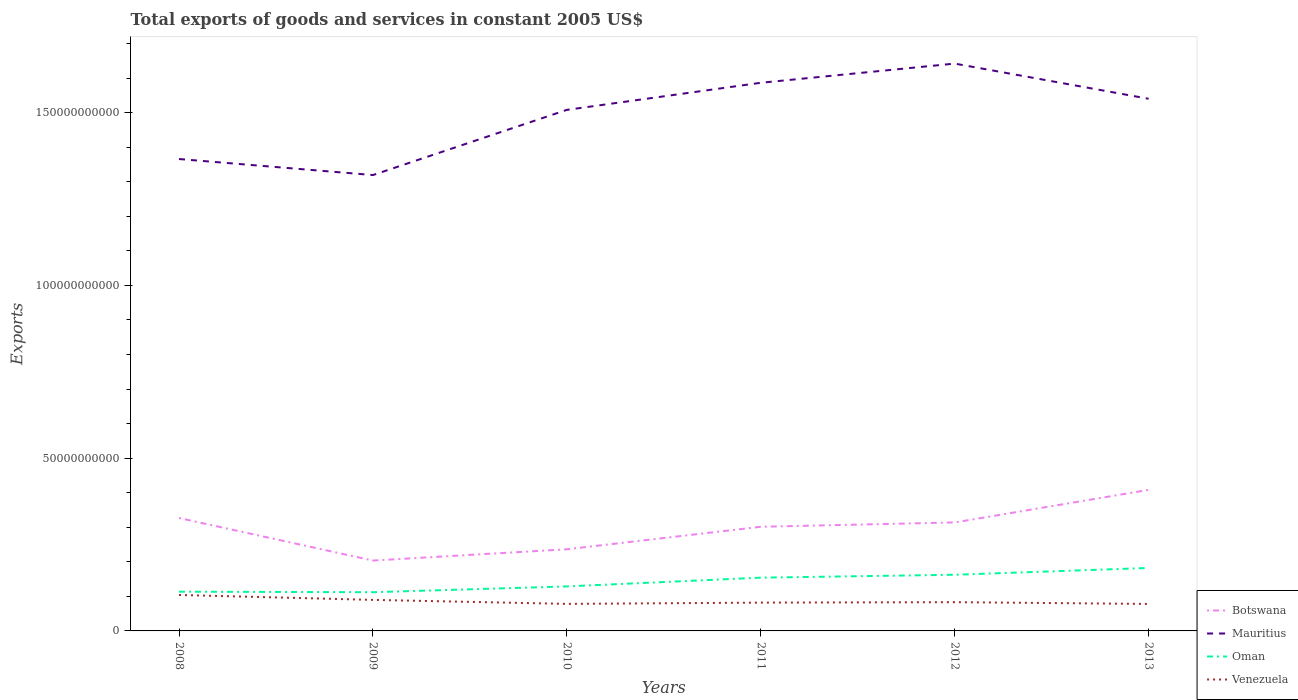How many different coloured lines are there?
Provide a short and direct response. 4. Is the number of lines equal to the number of legend labels?
Offer a terse response. Yes. Across all years, what is the maximum total exports of goods and services in Oman?
Your answer should be very brief. 1.12e+1. In which year was the total exports of goods and services in Oman maximum?
Your answer should be compact. 2009. What is the total total exports of goods and services in Venezuela in the graph?
Give a very brief answer. 2.22e+09. What is the difference between the highest and the second highest total exports of goods and services in Botswana?
Your answer should be very brief. 2.05e+1. What is the difference between the highest and the lowest total exports of goods and services in Botswana?
Keep it short and to the point. 4. How many lines are there?
Provide a succinct answer. 4. What is the difference between two consecutive major ticks on the Y-axis?
Give a very brief answer. 5.00e+1. Are the values on the major ticks of Y-axis written in scientific E-notation?
Offer a very short reply. No. Does the graph contain grids?
Offer a terse response. No. Where does the legend appear in the graph?
Offer a terse response. Bottom right. How many legend labels are there?
Make the answer very short. 4. How are the legend labels stacked?
Your answer should be compact. Vertical. What is the title of the graph?
Give a very brief answer. Total exports of goods and services in constant 2005 US$. Does "Bermuda" appear as one of the legend labels in the graph?
Your answer should be very brief. No. What is the label or title of the X-axis?
Make the answer very short. Years. What is the label or title of the Y-axis?
Provide a succinct answer. Exports. What is the Exports in Botswana in 2008?
Offer a terse response. 3.27e+1. What is the Exports in Mauritius in 2008?
Your response must be concise. 1.37e+11. What is the Exports of Oman in 2008?
Ensure brevity in your answer.  1.14e+1. What is the Exports in Venezuela in 2008?
Offer a terse response. 1.04e+1. What is the Exports of Botswana in 2009?
Give a very brief answer. 2.04e+1. What is the Exports of Mauritius in 2009?
Your answer should be very brief. 1.32e+11. What is the Exports of Oman in 2009?
Provide a succinct answer. 1.12e+1. What is the Exports in Venezuela in 2009?
Ensure brevity in your answer.  8.98e+09. What is the Exports of Botswana in 2010?
Give a very brief answer. 2.36e+1. What is the Exports of Mauritius in 2010?
Offer a very short reply. 1.51e+11. What is the Exports in Oman in 2010?
Ensure brevity in your answer.  1.29e+1. What is the Exports of Venezuela in 2010?
Give a very brief answer. 7.83e+09. What is the Exports in Botswana in 2011?
Your answer should be very brief. 3.01e+1. What is the Exports in Mauritius in 2011?
Your answer should be very brief. 1.59e+11. What is the Exports of Oman in 2011?
Your answer should be very brief. 1.54e+1. What is the Exports in Venezuela in 2011?
Your answer should be compact. 8.19e+09. What is the Exports of Botswana in 2012?
Provide a short and direct response. 3.14e+1. What is the Exports in Mauritius in 2012?
Give a very brief answer. 1.64e+11. What is the Exports in Oman in 2012?
Your answer should be compact. 1.63e+1. What is the Exports in Venezuela in 2012?
Offer a very short reply. 8.32e+09. What is the Exports in Botswana in 2013?
Ensure brevity in your answer.  4.08e+1. What is the Exports in Mauritius in 2013?
Keep it short and to the point. 1.54e+11. What is the Exports of Oman in 2013?
Keep it short and to the point. 1.82e+1. What is the Exports of Venezuela in 2013?
Offer a very short reply. 7.81e+09. Across all years, what is the maximum Exports of Botswana?
Your response must be concise. 4.08e+1. Across all years, what is the maximum Exports in Mauritius?
Make the answer very short. 1.64e+11. Across all years, what is the maximum Exports of Oman?
Provide a short and direct response. 1.82e+1. Across all years, what is the maximum Exports in Venezuela?
Your response must be concise. 1.04e+1. Across all years, what is the minimum Exports in Botswana?
Your answer should be compact. 2.04e+1. Across all years, what is the minimum Exports of Mauritius?
Give a very brief answer. 1.32e+11. Across all years, what is the minimum Exports of Oman?
Offer a very short reply. 1.12e+1. Across all years, what is the minimum Exports of Venezuela?
Your answer should be very brief. 7.81e+09. What is the total Exports in Botswana in the graph?
Ensure brevity in your answer.  1.79e+11. What is the total Exports of Mauritius in the graph?
Offer a terse response. 8.96e+11. What is the total Exports of Oman in the graph?
Give a very brief answer. 8.53e+1. What is the total Exports in Venezuela in the graph?
Provide a short and direct response. 5.15e+1. What is the difference between the Exports in Botswana in 2008 and that in 2009?
Your answer should be very brief. 1.23e+1. What is the difference between the Exports of Mauritius in 2008 and that in 2009?
Offer a terse response. 4.64e+09. What is the difference between the Exports in Oman in 2008 and that in 2009?
Keep it short and to the point. 1.51e+08. What is the difference between the Exports in Venezuela in 2008 and that in 2009?
Your answer should be compact. 1.42e+09. What is the difference between the Exports of Botswana in 2008 and that in 2010?
Ensure brevity in your answer.  9.05e+09. What is the difference between the Exports of Mauritius in 2008 and that in 2010?
Your answer should be very brief. -1.42e+1. What is the difference between the Exports of Oman in 2008 and that in 2010?
Your answer should be compact. -1.53e+09. What is the difference between the Exports in Venezuela in 2008 and that in 2010?
Provide a succinct answer. 2.58e+09. What is the difference between the Exports of Botswana in 2008 and that in 2011?
Keep it short and to the point. 2.54e+09. What is the difference between the Exports in Mauritius in 2008 and that in 2011?
Your response must be concise. -2.21e+1. What is the difference between the Exports in Oman in 2008 and that in 2011?
Provide a succinct answer. -4.06e+09. What is the difference between the Exports in Venezuela in 2008 and that in 2011?
Ensure brevity in your answer.  2.22e+09. What is the difference between the Exports in Botswana in 2008 and that in 2012?
Provide a succinct answer. 1.28e+09. What is the difference between the Exports of Mauritius in 2008 and that in 2012?
Make the answer very short. -2.76e+1. What is the difference between the Exports of Oman in 2008 and that in 2012?
Make the answer very short. -4.90e+09. What is the difference between the Exports of Venezuela in 2008 and that in 2012?
Give a very brief answer. 2.08e+09. What is the difference between the Exports in Botswana in 2008 and that in 2013?
Your answer should be compact. -8.14e+09. What is the difference between the Exports in Mauritius in 2008 and that in 2013?
Ensure brevity in your answer.  -1.74e+1. What is the difference between the Exports in Oman in 2008 and that in 2013?
Give a very brief answer. -6.87e+09. What is the difference between the Exports of Venezuela in 2008 and that in 2013?
Your response must be concise. 2.60e+09. What is the difference between the Exports of Botswana in 2009 and that in 2010?
Keep it short and to the point. -3.26e+09. What is the difference between the Exports in Mauritius in 2009 and that in 2010?
Provide a succinct answer. -1.89e+1. What is the difference between the Exports in Oman in 2009 and that in 2010?
Provide a short and direct response. -1.68e+09. What is the difference between the Exports of Venezuela in 2009 and that in 2010?
Offer a terse response. 1.16e+09. What is the difference between the Exports in Botswana in 2009 and that in 2011?
Offer a terse response. -9.77e+09. What is the difference between the Exports in Mauritius in 2009 and that in 2011?
Offer a very short reply. -2.67e+1. What is the difference between the Exports of Oman in 2009 and that in 2011?
Your response must be concise. -4.21e+09. What is the difference between the Exports in Venezuela in 2009 and that in 2011?
Provide a succinct answer. 7.92e+08. What is the difference between the Exports in Botswana in 2009 and that in 2012?
Make the answer very short. -1.10e+1. What is the difference between the Exports in Mauritius in 2009 and that in 2012?
Provide a short and direct response. -3.23e+1. What is the difference between the Exports of Oman in 2009 and that in 2012?
Ensure brevity in your answer.  -5.05e+09. What is the difference between the Exports of Venezuela in 2009 and that in 2012?
Provide a succinct answer. 6.61e+08. What is the difference between the Exports of Botswana in 2009 and that in 2013?
Keep it short and to the point. -2.05e+1. What is the difference between the Exports of Mauritius in 2009 and that in 2013?
Your answer should be compact. -2.21e+1. What is the difference between the Exports in Oman in 2009 and that in 2013?
Offer a very short reply. -7.02e+09. What is the difference between the Exports of Venezuela in 2009 and that in 2013?
Your response must be concise. 1.17e+09. What is the difference between the Exports in Botswana in 2010 and that in 2011?
Give a very brief answer. -6.51e+09. What is the difference between the Exports in Mauritius in 2010 and that in 2011?
Ensure brevity in your answer.  -7.84e+09. What is the difference between the Exports in Oman in 2010 and that in 2011?
Your answer should be very brief. -2.53e+09. What is the difference between the Exports in Venezuela in 2010 and that in 2011?
Ensure brevity in your answer.  -3.65e+08. What is the difference between the Exports of Botswana in 2010 and that in 2012?
Your answer should be very brief. -7.77e+09. What is the difference between the Exports in Mauritius in 2010 and that in 2012?
Keep it short and to the point. -1.34e+1. What is the difference between the Exports in Oman in 2010 and that in 2012?
Ensure brevity in your answer.  -3.37e+09. What is the difference between the Exports in Venezuela in 2010 and that in 2012?
Provide a succinct answer. -4.96e+08. What is the difference between the Exports of Botswana in 2010 and that in 2013?
Make the answer very short. -1.72e+1. What is the difference between the Exports in Mauritius in 2010 and that in 2013?
Your answer should be very brief. -3.21e+09. What is the difference between the Exports of Oman in 2010 and that in 2013?
Your answer should be very brief. -5.34e+09. What is the difference between the Exports in Venezuela in 2010 and that in 2013?
Your answer should be very brief. 1.78e+07. What is the difference between the Exports of Botswana in 2011 and that in 2012?
Your response must be concise. -1.26e+09. What is the difference between the Exports of Mauritius in 2011 and that in 2012?
Your response must be concise. -5.55e+09. What is the difference between the Exports in Oman in 2011 and that in 2012?
Offer a terse response. -8.39e+08. What is the difference between the Exports of Venezuela in 2011 and that in 2012?
Offer a very short reply. -1.31e+08. What is the difference between the Exports of Botswana in 2011 and that in 2013?
Make the answer very short. -1.07e+1. What is the difference between the Exports in Mauritius in 2011 and that in 2013?
Keep it short and to the point. 4.63e+09. What is the difference between the Exports in Oman in 2011 and that in 2013?
Your answer should be very brief. -2.81e+09. What is the difference between the Exports in Venezuela in 2011 and that in 2013?
Your response must be concise. 3.83e+08. What is the difference between the Exports in Botswana in 2012 and that in 2013?
Your answer should be compact. -9.42e+09. What is the difference between the Exports of Mauritius in 2012 and that in 2013?
Your response must be concise. 1.02e+1. What is the difference between the Exports in Oman in 2012 and that in 2013?
Make the answer very short. -1.97e+09. What is the difference between the Exports of Venezuela in 2012 and that in 2013?
Ensure brevity in your answer.  5.13e+08. What is the difference between the Exports in Botswana in 2008 and the Exports in Mauritius in 2009?
Provide a succinct answer. -9.93e+1. What is the difference between the Exports in Botswana in 2008 and the Exports in Oman in 2009?
Give a very brief answer. 2.15e+1. What is the difference between the Exports of Botswana in 2008 and the Exports of Venezuela in 2009?
Your answer should be compact. 2.37e+1. What is the difference between the Exports in Mauritius in 2008 and the Exports in Oman in 2009?
Your answer should be compact. 1.25e+11. What is the difference between the Exports in Mauritius in 2008 and the Exports in Venezuela in 2009?
Offer a very short reply. 1.28e+11. What is the difference between the Exports of Oman in 2008 and the Exports of Venezuela in 2009?
Your response must be concise. 2.37e+09. What is the difference between the Exports in Botswana in 2008 and the Exports in Mauritius in 2010?
Give a very brief answer. -1.18e+11. What is the difference between the Exports of Botswana in 2008 and the Exports of Oman in 2010?
Your response must be concise. 1.98e+1. What is the difference between the Exports of Botswana in 2008 and the Exports of Venezuela in 2010?
Your answer should be compact. 2.48e+1. What is the difference between the Exports of Mauritius in 2008 and the Exports of Oman in 2010?
Make the answer very short. 1.24e+11. What is the difference between the Exports in Mauritius in 2008 and the Exports in Venezuela in 2010?
Your answer should be compact. 1.29e+11. What is the difference between the Exports of Oman in 2008 and the Exports of Venezuela in 2010?
Ensure brevity in your answer.  3.53e+09. What is the difference between the Exports of Botswana in 2008 and the Exports of Mauritius in 2011?
Provide a succinct answer. -1.26e+11. What is the difference between the Exports in Botswana in 2008 and the Exports in Oman in 2011?
Provide a short and direct response. 1.73e+1. What is the difference between the Exports in Botswana in 2008 and the Exports in Venezuela in 2011?
Provide a succinct answer. 2.45e+1. What is the difference between the Exports in Mauritius in 2008 and the Exports in Oman in 2011?
Give a very brief answer. 1.21e+11. What is the difference between the Exports in Mauritius in 2008 and the Exports in Venezuela in 2011?
Offer a terse response. 1.28e+11. What is the difference between the Exports in Oman in 2008 and the Exports in Venezuela in 2011?
Give a very brief answer. 3.16e+09. What is the difference between the Exports of Botswana in 2008 and the Exports of Mauritius in 2012?
Give a very brief answer. -1.32e+11. What is the difference between the Exports of Botswana in 2008 and the Exports of Oman in 2012?
Provide a succinct answer. 1.64e+1. What is the difference between the Exports of Botswana in 2008 and the Exports of Venezuela in 2012?
Offer a terse response. 2.44e+1. What is the difference between the Exports in Mauritius in 2008 and the Exports in Oman in 2012?
Your answer should be compact. 1.20e+11. What is the difference between the Exports of Mauritius in 2008 and the Exports of Venezuela in 2012?
Make the answer very short. 1.28e+11. What is the difference between the Exports in Oman in 2008 and the Exports in Venezuela in 2012?
Ensure brevity in your answer.  3.03e+09. What is the difference between the Exports of Botswana in 2008 and the Exports of Mauritius in 2013?
Give a very brief answer. -1.21e+11. What is the difference between the Exports in Botswana in 2008 and the Exports in Oman in 2013?
Provide a short and direct response. 1.45e+1. What is the difference between the Exports of Botswana in 2008 and the Exports of Venezuela in 2013?
Offer a very short reply. 2.49e+1. What is the difference between the Exports in Mauritius in 2008 and the Exports in Oman in 2013?
Give a very brief answer. 1.18e+11. What is the difference between the Exports in Mauritius in 2008 and the Exports in Venezuela in 2013?
Your answer should be very brief. 1.29e+11. What is the difference between the Exports of Oman in 2008 and the Exports of Venezuela in 2013?
Give a very brief answer. 3.55e+09. What is the difference between the Exports in Botswana in 2009 and the Exports in Mauritius in 2010?
Your answer should be very brief. -1.30e+11. What is the difference between the Exports of Botswana in 2009 and the Exports of Oman in 2010?
Offer a terse response. 7.48e+09. What is the difference between the Exports of Botswana in 2009 and the Exports of Venezuela in 2010?
Your answer should be very brief. 1.25e+1. What is the difference between the Exports in Mauritius in 2009 and the Exports in Oman in 2010?
Your answer should be compact. 1.19e+11. What is the difference between the Exports of Mauritius in 2009 and the Exports of Venezuela in 2010?
Provide a short and direct response. 1.24e+11. What is the difference between the Exports in Oman in 2009 and the Exports in Venezuela in 2010?
Offer a terse response. 3.38e+09. What is the difference between the Exports of Botswana in 2009 and the Exports of Mauritius in 2011?
Provide a short and direct response. -1.38e+11. What is the difference between the Exports in Botswana in 2009 and the Exports in Oman in 2011?
Provide a short and direct response. 4.95e+09. What is the difference between the Exports of Botswana in 2009 and the Exports of Venezuela in 2011?
Provide a succinct answer. 1.22e+1. What is the difference between the Exports of Mauritius in 2009 and the Exports of Oman in 2011?
Your answer should be compact. 1.17e+11. What is the difference between the Exports in Mauritius in 2009 and the Exports in Venezuela in 2011?
Give a very brief answer. 1.24e+11. What is the difference between the Exports in Oman in 2009 and the Exports in Venezuela in 2011?
Make the answer very short. 3.01e+09. What is the difference between the Exports of Botswana in 2009 and the Exports of Mauritius in 2012?
Keep it short and to the point. -1.44e+11. What is the difference between the Exports of Botswana in 2009 and the Exports of Oman in 2012?
Offer a terse response. 4.11e+09. What is the difference between the Exports of Botswana in 2009 and the Exports of Venezuela in 2012?
Your response must be concise. 1.20e+1. What is the difference between the Exports of Mauritius in 2009 and the Exports of Oman in 2012?
Your answer should be very brief. 1.16e+11. What is the difference between the Exports of Mauritius in 2009 and the Exports of Venezuela in 2012?
Your answer should be compact. 1.24e+11. What is the difference between the Exports in Oman in 2009 and the Exports in Venezuela in 2012?
Your answer should be very brief. 2.88e+09. What is the difference between the Exports in Botswana in 2009 and the Exports in Mauritius in 2013?
Keep it short and to the point. -1.34e+11. What is the difference between the Exports of Botswana in 2009 and the Exports of Oman in 2013?
Offer a very short reply. 2.14e+09. What is the difference between the Exports in Botswana in 2009 and the Exports in Venezuela in 2013?
Your answer should be compact. 1.26e+1. What is the difference between the Exports in Mauritius in 2009 and the Exports in Oman in 2013?
Your answer should be compact. 1.14e+11. What is the difference between the Exports in Mauritius in 2009 and the Exports in Venezuela in 2013?
Provide a succinct answer. 1.24e+11. What is the difference between the Exports of Oman in 2009 and the Exports of Venezuela in 2013?
Make the answer very short. 3.40e+09. What is the difference between the Exports of Botswana in 2010 and the Exports of Mauritius in 2011?
Offer a terse response. -1.35e+11. What is the difference between the Exports of Botswana in 2010 and the Exports of Oman in 2011?
Give a very brief answer. 8.22e+09. What is the difference between the Exports of Botswana in 2010 and the Exports of Venezuela in 2011?
Your answer should be compact. 1.54e+1. What is the difference between the Exports in Mauritius in 2010 and the Exports in Oman in 2011?
Your response must be concise. 1.35e+11. What is the difference between the Exports in Mauritius in 2010 and the Exports in Venezuela in 2011?
Make the answer very short. 1.43e+11. What is the difference between the Exports in Oman in 2010 and the Exports in Venezuela in 2011?
Your response must be concise. 4.69e+09. What is the difference between the Exports in Botswana in 2010 and the Exports in Mauritius in 2012?
Give a very brief answer. -1.41e+11. What is the difference between the Exports in Botswana in 2010 and the Exports in Oman in 2012?
Provide a succinct answer. 7.38e+09. What is the difference between the Exports of Botswana in 2010 and the Exports of Venezuela in 2012?
Provide a succinct answer. 1.53e+1. What is the difference between the Exports in Mauritius in 2010 and the Exports in Oman in 2012?
Keep it short and to the point. 1.35e+11. What is the difference between the Exports of Mauritius in 2010 and the Exports of Venezuela in 2012?
Provide a short and direct response. 1.42e+11. What is the difference between the Exports in Oman in 2010 and the Exports in Venezuela in 2012?
Offer a terse response. 4.56e+09. What is the difference between the Exports in Botswana in 2010 and the Exports in Mauritius in 2013?
Offer a terse response. -1.30e+11. What is the difference between the Exports in Botswana in 2010 and the Exports in Oman in 2013?
Your answer should be very brief. 5.41e+09. What is the difference between the Exports in Botswana in 2010 and the Exports in Venezuela in 2013?
Provide a succinct answer. 1.58e+1. What is the difference between the Exports of Mauritius in 2010 and the Exports of Oman in 2013?
Ensure brevity in your answer.  1.33e+11. What is the difference between the Exports of Mauritius in 2010 and the Exports of Venezuela in 2013?
Ensure brevity in your answer.  1.43e+11. What is the difference between the Exports in Oman in 2010 and the Exports in Venezuela in 2013?
Your response must be concise. 5.07e+09. What is the difference between the Exports in Botswana in 2011 and the Exports in Mauritius in 2012?
Offer a terse response. -1.34e+11. What is the difference between the Exports of Botswana in 2011 and the Exports of Oman in 2012?
Keep it short and to the point. 1.39e+1. What is the difference between the Exports in Botswana in 2011 and the Exports in Venezuela in 2012?
Give a very brief answer. 2.18e+1. What is the difference between the Exports of Mauritius in 2011 and the Exports of Oman in 2012?
Offer a very short reply. 1.42e+11. What is the difference between the Exports in Mauritius in 2011 and the Exports in Venezuela in 2012?
Ensure brevity in your answer.  1.50e+11. What is the difference between the Exports of Oman in 2011 and the Exports of Venezuela in 2012?
Provide a short and direct response. 7.09e+09. What is the difference between the Exports of Botswana in 2011 and the Exports of Mauritius in 2013?
Provide a succinct answer. -1.24e+11. What is the difference between the Exports in Botswana in 2011 and the Exports in Oman in 2013?
Your answer should be very brief. 1.19e+1. What is the difference between the Exports of Botswana in 2011 and the Exports of Venezuela in 2013?
Offer a terse response. 2.23e+1. What is the difference between the Exports of Mauritius in 2011 and the Exports of Oman in 2013?
Make the answer very short. 1.40e+11. What is the difference between the Exports of Mauritius in 2011 and the Exports of Venezuela in 2013?
Your answer should be very brief. 1.51e+11. What is the difference between the Exports of Oman in 2011 and the Exports of Venezuela in 2013?
Your answer should be very brief. 7.61e+09. What is the difference between the Exports in Botswana in 2012 and the Exports in Mauritius in 2013?
Offer a very short reply. -1.23e+11. What is the difference between the Exports of Botswana in 2012 and the Exports of Oman in 2013?
Offer a terse response. 1.32e+1. What is the difference between the Exports of Botswana in 2012 and the Exports of Venezuela in 2013?
Keep it short and to the point. 2.36e+1. What is the difference between the Exports of Mauritius in 2012 and the Exports of Oman in 2013?
Offer a terse response. 1.46e+11. What is the difference between the Exports of Mauritius in 2012 and the Exports of Venezuela in 2013?
Your answer should be very brief. 1.56e+11. What is the difference between the Exports of Oman in 2012 and the Exports of Venezuela in 2013?
Your answer should be compact. 8.45e+09. What is the average Exports of Botswana per year?
Provide a succinct answer. 2.98e+1. What is the average Exports in Mauritius per year?
Your answer should be compact. 1.49e+11. What is the average Exports of Oman per year?
Provide a short and direct response. 1.42e+1. What is the average Exports of Venezuela per year?
Your answer should be very brief. 8.59e+09. In the year 2008, what is the difference between the Exports of Botswana and Exports of Mauritius?
Your response must be concise. -1.04e+11. In the year 2008, what is the difference between the Exports of Botswana and Exports of Oman?
Offer a very short reply. 2.13e+1. In the year 2008, what is the difference between the Exports in Botswana and Exports in Venezuela?
Provide a succinct answer. 2.23e+1. In the year 2008, what is the difference between the Exports in Mauritius and Exports in Oman?
Your answer should be very brief. 1.25e+11. In the year 2008, what is the difference between the Exports of Mauritius and Exports of Venezuela?
Keep it short and to the point. 1.26e+11. In the year 2008, what is the difference between the Exports of Oman and Exports of Venezuela?
Provide a succinct answer. 9.49e+08. In the year 2009, what is the difference between the Exports in Botswana and Exports in Mauritius?
Provide a succinct answer. -1.12e+11. In the year 2009, what is the difference between the Exports in Botswana and Exports in Oman?
Your answer should be compact. 9.16e+09. In the year 2009, what is the difference between the Exports in Botswana and Exports in Venezuela?
Make the answer very short. 1.14e+1. In the year 2009, what is the difference between the Exports of Mauritius and Exports of Oman?
Your answer should be compact. 1.21e+11. In the year 2009, what is the difference between the Exports in Mauritius and Exports in Venezuela?
Provide a succinct answer. 1.23e+11. In the year 2009, what is the difference between the Exports of Oman and Exports of Venezuela?
Make the answer very short. 2.22e+09. In the year 2010, what is the difference between the Exports in Botswana and Exports in Mauritius?
Your answer should be very brief. -1.27e+11. In the year 2010, what is the difference between the Exports in Botswana and Exports in Oman?
Your response must be concise. 1.07e+1. In the year 2010, what is the difference between the Exports in Botswana and Exports in Venezuela?
Make the answer very short. 1.58e+1. In the year 2010, what is the difference between the Exports in Mauritius and Exports in Oman?
Offer a terse response. 1.38e+11. In the year 2010, what is the difference between the Exports in Mauritius and Exports in Venezuela?
Your answer should be very brief. 1.43e+11. In the year 2010, what is the difference between the Exports in Oman and Exports in Venezuela?
Keep it short and to the point. 5.06e+09. In the year 2011, what is the difference between the Exports of Botswana and Exports of Mauritius?
Offer a very short reply. -1.28e+11. In the year 2011, what is the difference between the Exports of Botswana and Exports of Oman?
Make the answer very short. 1.47e+1. In the year 2011, what is the difference between the Exports in Botswana and Exports in Venezuela?
Keep it short and to the point. 2.19e+1. In the year 2011, what is the difference between the Exports in Mauritius and Exports in Oman?
Make the answer very short. 1.43e+11. In the year 2011, what is the difference between the Exports of Mauritius and Exports of Venezuela?
Your answer should be very brief. 1.50e+11. In the year 2011, what is the difference between the Exports in Oman and Exports in Venezuela?
Ensure brevity in your answer.  7.22e+09. In the year 2012, what is the difference between the Exports of Botswana and Exports of Mauritius?
Offer a very short reply. -1.33e+11. In the year 2012, what is the difference between the Exports in Botswana and Exports in Oman?
Make the answer very short. 1.51e+1. In the year 2012, what is the difference between the Exports in Botswana and Exports in Venezuela?
Keep it short and to the point. 2.31e+1. In the year 2012, what is the difference between the Exports in Mauritius and Exports in Oman?
Give a very brief answer. 1.48e+11. In the year 2012, what is the difference between the Exports of Mauritius and Exports of Venezuela?
Your answer should be very brief. 1.56e+11. In the year 2012, what is the difference between the Exports of Oman and Exports of Venezuela?
Give a very brief answer. 7.93e+09. In the year 2013, what is the difference between the Exports of Botswana and Exports of Mauritius?
Provide a short and direct response. -1.13e+11. In the year 2013, what is the difference between the Exports in Botswana and Exports in Oman?
Make the answer very short. 2.26e+1. In the year 2013, what is the difference between the Exports of Botswana and Exports of Venezuela?
Keep it short and to the point. 3.30e+1. In the year 2013, what is the difference between the Exports in Mauritius and Exports in Oman?
Ensure brevity in your answer.  1.36e+11. In the year 2013, what is the difference between the Exports in Mauritius and Exports in Venezuela?
Keep it short and to the point. 1.46e+11. In the year 2013, what is the difference between the Exports of Oman and Exports of Venezuela?
Offer a very short reply. 1.04e+1. What is the ratio of the Exports of Botswana in 2008 to that in 2009?
Your answer should be compact. 1.6. What is the ratio of the Exports in Mauritius in 2008 to that in 2009?
Your response must be concise. 1.04. What is the ratio of the Exports of Oman in 2008 to that in 2009?
Your answer should be very brief. 1.01. What is the ratio of the Exports in Venezuela in 2008 to that in 2009?
Offer a very short reply. 1.16. What is the ratio of the Exports in Botswana in 2008 to that in 2010?
Provide a succinct answer. 1.38. What is the ratio of the Exports in Mauritius in 2008 to that in 2010?
Your answer should be very brief. 0.91. What is the ratio of the Exports of Oman in 2008 to that in 2010?
Offer a very short reply. 0.88. What is the ratio of the Exports in Venezuela in 2008 to that in 2010?
Ensure brevity in your answer.  1.33. What is the ratio of the Exports in Botswana in 2008 to that in 2011?
Offer a very short reply. 1.08. What is the ratio of the Exports in Mauritius in 2008 to that in 2011?
Give a very brief answer. 0.86. What is the ratio of the Exports in Oman in 2008 to that in 2011?
Your answer should be very brief. 0.74. What is the ratio of the Exports in Venezuela in 2008 to that in 2011?
Keep it short and to the point. 1.27. What is the ratio of the Exports in Botswana in 2008 to that in 2012?
Your answer should be compact. 1.04. What is the ratio of the Exports of Mauritius in 2008 to that in 2012?
Keep it short and to the point. 0.83. What is the ratio of the Exports in Oman in 2008 to that in 2012?
Offer a terse response. 0.7. What is the ratio of the Exports in Venezuela in 2008 to that in 2012?
Offer a very short reply. 1.25. What is the ratio of the Exports in Botswana in 2008 to that in 2013?
Your answer should be very brief. 0.8. What is the ratio of the Exports of Mauritius in 2008 to that in 2013?
Provide a short and direct response. 0.89. What is the ratio of the Exports in Oman in 2008 to that in 2013?
Offer a very short reply. 0.62. What is the ratio of the Exports of Venezuela in 2008 to that in 2013?
Your answer should be very brief. 1.33. What is the ratio of the Exports of Botswana in 2009 to that in 2010?
Provide a short and direct response. 0.86. What is the ratio of the Exports in Mauritius in 2009 to that in 2010?
Offer a terse response. 0.87. What is the ratio of the Exports in Oman in 2009 to that in 2010?
Your response must be concise. 0.87. What is the ratio of the Exports of Venezuela in 2009 to that in 2010?
Provide a succinct answer. 1.15. What is the ratio of the Exports of Botswana in 2009 to that in 2011?
Provide a succinct answer. 0.68. What is the ratio of the Exports in Mauritius in 2009 to that in 2011?
Your answer should be compact. 0.83. What is the ratio of the Exports in Oman in 2009 to that in 2011?
Your answer should be compact. 0.73. What is the ratio of the Exports in Venezuela in 2009 to that in 2011?
Make the answer very short. 1.1. What is the ratio of the Exports of Botswana in 2009 to that in 2012?
Offer a very short reply. 0.65. What is the ratio of the Exports of Mauritius in 2009 to that in 2012?
Your answer should be compact. 0.8. What is the ratio of the Exports in Oman in 2009 to that in 2012?
Your answer should be very brief. 0.69. What is the ratio of the Exports of Venezuela in 2009 to that in 2012?
Keep it short and to the point. 1.08. What is the ratio of the Exports in Botswana in 2009 to that in 2013?
Keep it short and to the point. 0.5. What is the ratio of the Exports of Mauritius in 2009 to that in 2013?
Ensure brevity in your answer.  0.86. What is the ratio of the Exports in Oman in 2009 to that in 2013?
Provide a short and direct response. 0.61. What is the ratio of the Exports in Venezuela in 2009 to that in 2013?
Give a very brief answer. 1.15. What is the ratio of the Exports of Botswana in 2010 to that in 2011?
Offer a terse response. 0.78. What is the ratio of the Exports in Mauritius in 2010 to that in 2011?
Your answer should be compact. 0.95. What is the ratio of the Exports of Oman in 2010 to that in 2011?
Offer a very short reply. 0.84. What is the ratio of the Exports in Venezuela in 2010 to that in 2011?
Offer a terse response. 0.96. What is the ratio of the Exports of Botswana in 2010 to that in 2012?
Offer a very short reply. 0.75. What is the ratio of the Exports of Mauritius in 2010 to that in 2012?
Offer a very short reply. 0.92. What is the ratio of the Exports of Oman in 2010 to that in 2012?
Offer a terse response. 0.79. What is the ratio of the Exports in Venezuela in 2010 to that in 2012?
Offer a very short reply. 0.94. What is the ratio of the Exports of Botswana in 2010 to that in 2013?
Your answer should be very brief. 0.58. What is the ratio of the Exports in Mauritius in 2010 to that in 2013?
Your answer should be compact. 0.98. What is the ratio of the Exports in Oman in 2010 to that in 2013?
Offer a terse response. 0.71. What is the ratio of the Exports of Venezuela in 2010 to that in 2013?
Your answer should be compact. 1. What is the ratio of the Exports in Mauritius in 2011 to that in 2012?
Make the answer very short. 0.97. What is the ratio of the Exports of Oman in 2011 to that in 2012?
Your response must be concise. 0.95. What is the ratio of the Exports of Venezuela in 2011 to that in 2012?
Provide a short and direct response. 0.98. What is the ratio of the Exports in Botswana in 2011 to that in 2013?
Keep it short and to the point. 0.74. What is the ratio of the Exports in Oman in 2011 to that in 2013?
Give a very brief answer. 0.85. What is the ratio of the Exports of Venezuela in 2011 to that in 2013?
Keep it short and to the point. 1.05. What is the ratio of the Exports of Botswana in 2012 to that in 2013?
Offer a terse response. 0.77. What is the ratio of the Exports in Mauritius in 2012 to that in 2013?
Offer a very short reply. 1.07. What is the ratio of the Exports of Oman in 2012 to that in 2013?
Provide a succinct answer. 0.89. What is the ratio of the Exports of Venezuela in 2012 to that in 2013?
Keep it short and to the point. 1.07. What is the difference between the highest and the second highest Exports in Botswana?
Keep it short and to the point. 8.14e+09. What is the difference between the highest and the second highest Exports in Mauritius?
Your response must be concise. 5.55e+09. What is the difference between the highest and the second highest Exports of Oman?
Your answer should be very brief. 1.97e+09. What is the difference between the highest and the second highest Exports of Venezuela?
Keep it short and to the point. 1.42e+09. What is the difference between the highest and the lowest Exports in Botswana?
Ensure brevity in your answer.  2.05e+1. What is the difference between the highest and the lowest Exports of Mauritius?
Offer a terse response. 3.23e+1. What is the difference between the highest and the lowest Exports of Oman?
Your answer should be compact. 7.02e+09. What is the difference between the highest and the lowest Exports of Venezuela?
Your answer should be compact. 2.60e+09. 